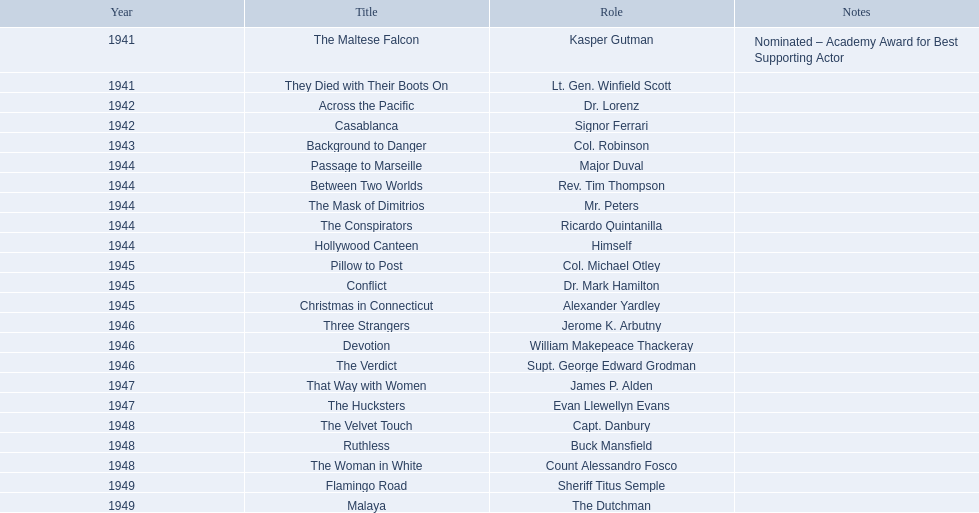What are the films? The Maltese Falcon, They Died with Their Boots On, Across the Pacific, Casablanca, Background to Danger, Passage to Marseille, Between Two Worlds, The Mask of Dimitrios, The Conspirators, Hollywood Canteen, Pillow to Post, Conflict, Christmas in Connecticut, Three Strangers, Devotion, The Verdict, That Way with Women, The Hucksters, The Velvet Touch, Ruthless, The Woman in White, Flamingo Road, Malaya. Among them, for which did he receive an oscar nomination? The Maltese Falcon. What films are included? The Maltese Falcon, They Died with Their Boots On, Across the Pacific, Casablanca, Background to Danger, Passage to Marseille, Between Two Worlds, The Mask of Dimitrios, The Conspirators, Hollywood Canteen, Pillow to Post, Conflict, Christmas in Connecticut, Three Strangers, Devotion, The Verdict, That Way with Women, The Hucksters, The Velvet Touch, Ruthless, The Woman in White, Flamingo Road, Malaya. Among them, in which ones was he nominated for an oscar? The Maltese Falcon. 